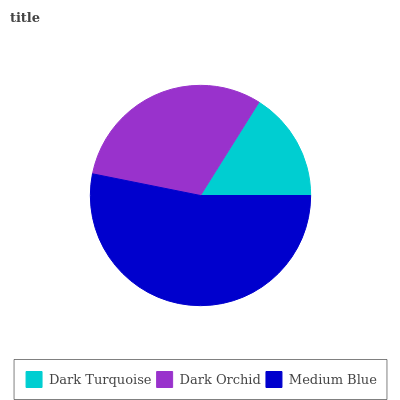Is Dark Turquoise the minimum?
Answer yes or no. Yes. Is Medium Blue the maximum?
Answer yes or no. Yes. Is Dark Orchid the minimum?
Answer yes or no. No. Is Dark Orchid the maximum?
Answer yes or no. No. Is Dark Orchid greater than Dark Turquoise?
Answer yes or no. Yes. Is Dark Turquoise less than Dark Orchid?
Answer yes or no. Yes. Is Dark Turquoise greater than Dark Orchid?
Answer yes or no. No. Is Dark Orchid less than Dark Turquoise?
Answer yes or no. No. Is Dark Orchid the high median?
Answer yes or no. Yes. Is Dark Orchid the low median?
Answer yes or no. Yes. Is Dark Turquoise the high median?
Answer yes or no. No. Is Dark Turquoise the low median?
Answer yes or no. No. 